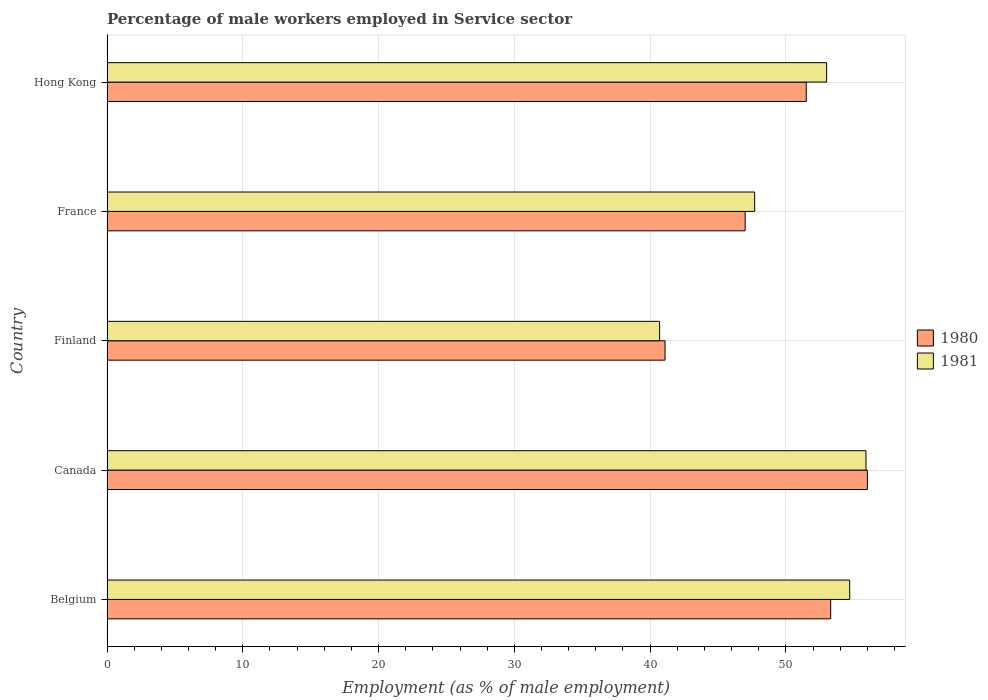How many groups of bars are there?
Make the answer very short. 5. Are the number of bars per tick equal to the number of legend labels?
Offer a very short reply. Yes. Are the number of bars on each tick of the Y-axis equal?
Give a very brief answer. Yes. How many bars are there on the 1st tick from the top?
Give a very brief answer. 2. How many bars are there on the 4th tick from the bottom?
Keep it short and to the point. 2. In how many cases, is the number of bars for a given country not equal to the number of legend labels?
Your response must be concise. 0. What is the percentage of male workers employed in Service sector in 1980 in Canada?
Provide a succinct answer. 56. Across all countries, what is the maximum percentage of male workers employed in Service sector in 1981?
Offer a very short reply. 55.9. Across all countries, what is the minimum percentage of male workers employed in Service sector in 1981?
Ensure brevity in your answer.  40.7. What is the total percentage of male workers employed in Service sector in 1980 in the graph?
Ensure brevity in your answer.  248.9. What is the difference between the percentage of male workers employed in Service sector in 1980 in Hong Kong and the percentage of male workers employed in Service sector in 1981 in Belgium?
Make the answer very short. -3.2. What is the average percentage of male workers employed in Service sector in 1980 per country?
Provide a short and direct response. 49.78. What is the difference between the percentage of male workers employed in Service sector in 1981 and percentage of male workers employed in Service sector in 1980 in Belgium?
Offer a very short reply. 1.4. What is the ratio of the percentage of male workers employed in Service sector in 1981 in Belgium to that in Canada?
Ensure brevity in your answer.  0.98. Is the percentage of male workers employed in Service sector in 1981 in Belgium less than that in Canada?
Give a very brief answer. Yes. Is the difference between the percentage of male workers employed in Service sector in 1981 in Belgium and Canada greater than the difference between the percentage of male workers employed in Service sector in 1980 in Belgium and Canada?
Make the answer very short. Yes. What is the difference between the highest and the second highest percentage of male workers employed in Service sector in 1980?
Offer a terse response. 2.7. What is the difference between the highest and the lowest percentage of male workers employed in Service sector in 1980?
Your answer should be compact. 14.9. Is the sum of the percentage of male workers employed in Service sector in 1980 in Canada and France greater than the maximum percentage of male workers employed in Service sector in 1981 across all countries?
Make the answer very short. Yes. What does the 1st bar from the top in Belgium represents?
Give a very brief answer. 1981. Are all the bars in the graph horizontal?
Ensure brevity in your answer.  Yes. How many countries are there in the graph?
Give a very brief answer. 5. Are the values on the major ticks of X-axis written in scientific E-notation?
Give a very brief answer. No. Does the graph contain any zero values?
Your answer should be compact. No. Does the graph contain grids?
Give a very brief answer. Yes. Where does the legend appear in the graph?
Your answer should be very brief. Center right. How many legend labels are there?
Give a very brief answer. 2. What is the title of the graph?
Provide a short and direct response. Percentage of male workers employed in Service sector. Does "2014" appear as one of the legend labels in the graph?
Keep it short and to the point. No. What is the label or title of the X-axis?
Your answer should be very brief. Employment (as % of male employment). What is the Employment (as % of male employment) of 1980 in Belgium?
Your answer should be very brief. 53.3. What is the Employment (as % of male employment) of 1981 in Belgium?
Your answer should be very brief. 54.7. What is the Employment (as % of male employment) in 1981 in Canada?
Offer a terse response. 55.9. What is the Employment (as % of male employment) in 1980 in Finland?
Give a very brief answer. 41.1. What is the Employment (as % of male employment) of 1981 in Finland?
Offer a very short reply. 40.7. What is the Employment (as % of male employment) in 1980 in France?
Make the answer very short. 47. What is the Employment (as % of male employment) of 1981 in France?
Provide a short and direct response. 47.7. What is the Employment (as % of male employment) of 1980 in Hong Kong?
Your answer should be very brief. 51.5. Across all countries, what is the maximum Employment (as % of male employment) in 1980?
Your response must be concise. 56. Across all countries, what is the maximum Employment (as % of male employment) in 1981?
Provide a short and direct response. 55.9. Across all countries, what is the minimum Employment (as % of male employment) in 1980?
Your response must be concise. 41.1. Across all countries, what is the minimum Employment (as % of male employment) in 1981?
Your response must be concise. 40.7. What is the total Employment (as % of male employment) of 1980 in the graph?
Your response must be concise. 248.9. What is the total Employment (as % of male employment) in 1981 in the graph?
Offer a very short reply. 252. What is the difference between the Employment (as % of male employment) in 1981 in Belgium and that in Canada?
Provide a succinct answer. -1.2. What is the difference between the Employment (as % of male employment) in 1981 in Canada and that in Finland?
Offer a terse response. 15.2. What is the difference between the Employment (as % of male employment) of 1980 in Canada and that in France?
Keep it short and to the point. 9. What is the difference between the Employment (as % of male employment) in 1981 in Canada and that in France?
Provide a short and direct response. 8.2. What is the difference between the Employment (as % of male employment) of 1981 in Canada and that in Hong Kong?
Provide a short and direct response. 2.9. What is the difference between the Employment (as % of male employment) in 1980 in Finland and that in France?
Your answer should be very brief. -5.9. What is the difference between the Employment (as % of male employment) in 1980 in France and that in Hong Kong?
Offer a terse response. -4.5. What is the difference between the Employment (as % of male employment) of 1980 in Belgium and the Employment (as % of male employment) of 1981 in Canada?
Your answer should be compact. -2.6. What is the difference between the Employment (as % of male employment) in 1980 in Belgium and the Employment (as % of male employment) in 1981 in France?
Your response must be concise. 5.6. What is the difference between the Employment (as % of male employment) of 1980 in Canada and the Employment (as % of male employment) of 1981 in Finland?
Keep it short and to the point. 15.3. What is the difference between the Employment (as % of male employment) in 1980 in Canada and the Employment (as % of male employment) in 1981 in Hong Kong?
Give a very brief answer. 3. What is the difference between the Employment (as % of male employment) in 1980 in Finland and the Employment (as % of male employment) in 1981 in France?
Ensure brevity in your answer.  -6.6. What is the difference between the Employment (as % of male employment) in 1980 in Finland and the Employment (as % of male employment) in 1981 in Hong Kong?
Your answer should be compact. -11.9. What is the average Employment (as % of male employment) of 1980 per country?
Your response must be concise. 49.78. What is the average Employment (as % of male employment) in 1981 per country?
Keep it short and to the point. 50.4. What is the difference between the Employment (as % of male employment) of 1980 and Employment (as % of male employment) of 1981 in Canada?
Provide a short and direct response. 0.1. What is the ratio of the Employment (as % of male employment) of 1980 in Belgium to that in Canada?
Offer a terse response. 0.95. What is the ratio of the Employment (as % of male employment) of 1981 in Belgium to that in Canada?
Your answer should be very brief. 0.98. What is the ratio of the Employment (as % of male employment) in 1980 in Belgium to that in Finland?
Your response must be concise. 1.3. What is the ratio of the Employment (as % of male employment) in 1981 in Belgium to that in Finland?
Provide a succinct answer. 1.34. What is the ratio of the Employment (as % of male employment) of 1980 in Belgium to that in France?
Provide a short and direct response. 1.13. What is the ratio of the Employment (as % of male employment) in 1981 in Belgium to that in France?
Make the answer very short. 1.15. What is the ratio of the Employment (as % of male employment) of 1980 in Belgium to that in Hong Kong?
Offer a very short reply. 1.03. What is the ratio of the Employment (as % of male employment) of 1981 in Belgium to that in Hong Kong?
Provide a short and direct response. 1.03. What is the ratio of the Employment (as % of male employment) of 1980 in Canada to that in Finland?
Ensure brevity in your answer.  1.36. What is the ratio of the Employment (as % of male employment) in 1981 in Canada to that in Finland?
Ensure brevity in your answer.  1.37. What is the ratio of the Employment (as % of male employment) of 1980 in Canada to that in France?
Give a very brief answer. 1.19. What is the ratio of the Employment (as % of male employment) of 1981 in Canada to that in France?
Give a very brief answer. 1.17. What is the ratio of the Employment (as % of male employment) in 1980 in Canada to that in Hong Kong?
Offer a terse response. 1.09. What is the ratio of the Employment (as % of male employment) in 1981 in Canada to that in Hong Kong?
Your answer should be compact. 1.05. What is the ratio of the Employment (as % of male employment) in 1980 in Finland to that in France?
Provide a short and direct response. 0.87. What is the ratio of the Employment (as % of male employment) of 1981 in Finland to that in France?
Keep it short and to the point. 0.85. What is the ratio of the Employment (as % of male employment) of 1980 in Finland to that in Hong Kong?
Your answer should be very brief. 0.8. What is the ratio of the Employment (as % of male employment) in 1981 in Finland to that in Hong Kong?
Your response must be concise. 0.77. What is the ratio of the Employment (as % of male employment) in 1980 in France to that in Hong Kong?
Offer a terse response. 0.91. 